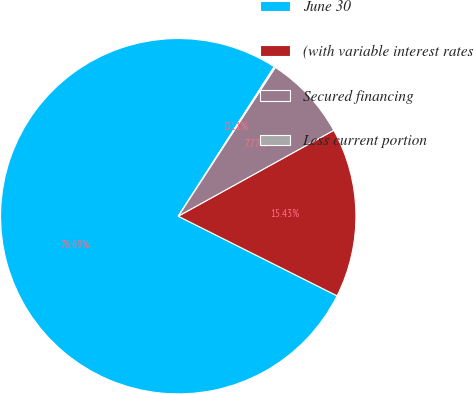Convert chart to OTSL. <chart><loc_0><loc_0><loc_500><loc_500><pie_chart><fcel>June 30<fcel>(with variable interest rates<fcel>Secured financing<fcel>Less current portion<nl><fcel>76.7%<fcel>15.43%<fcel>7.77%<fcel>0.11%<nl></chart> 